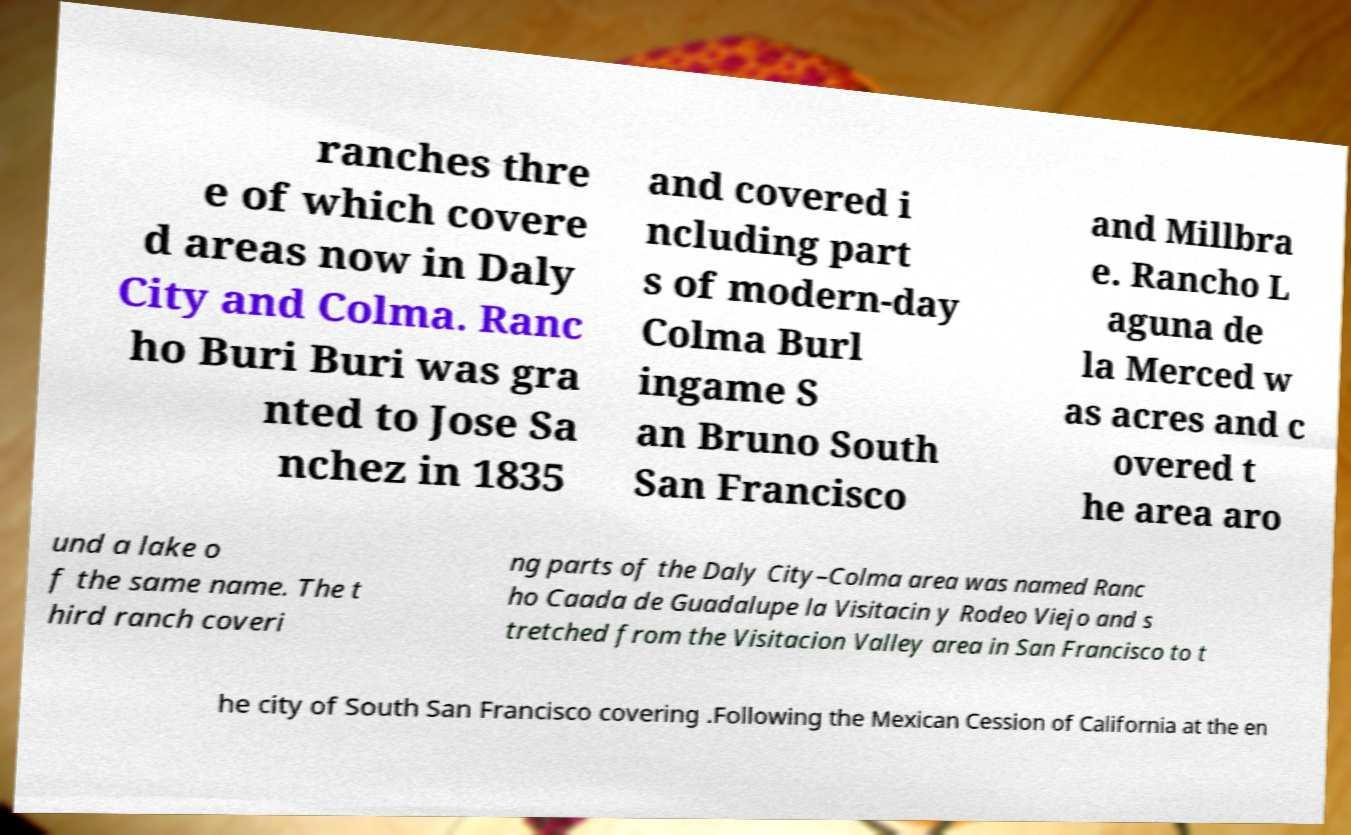Please identify and transcribe the text found in this image. ranches thre e of which covere d areas now in Daly City and Colma. Ranc ho Buri Buri was gra nted to Jose Sa nchez in 1835 and covered i ncluding part s of modern-day Colma Burl ingame S an Bruno South San Francisco and Millbra e. Rancho L aguna de la Merced w as acres and c overed t he area aro und a lake o f the same name. The t hird ranch coveri ng parts of the Daly City–Colma area was named Ranc ho Caada de Guadalupe la Visitacin y Rodeo Viejo and s tretched from the Visitacion Valley area in San Francisco to t he city of South San Francisco covering .Following the Mexican Cession of California at the en 